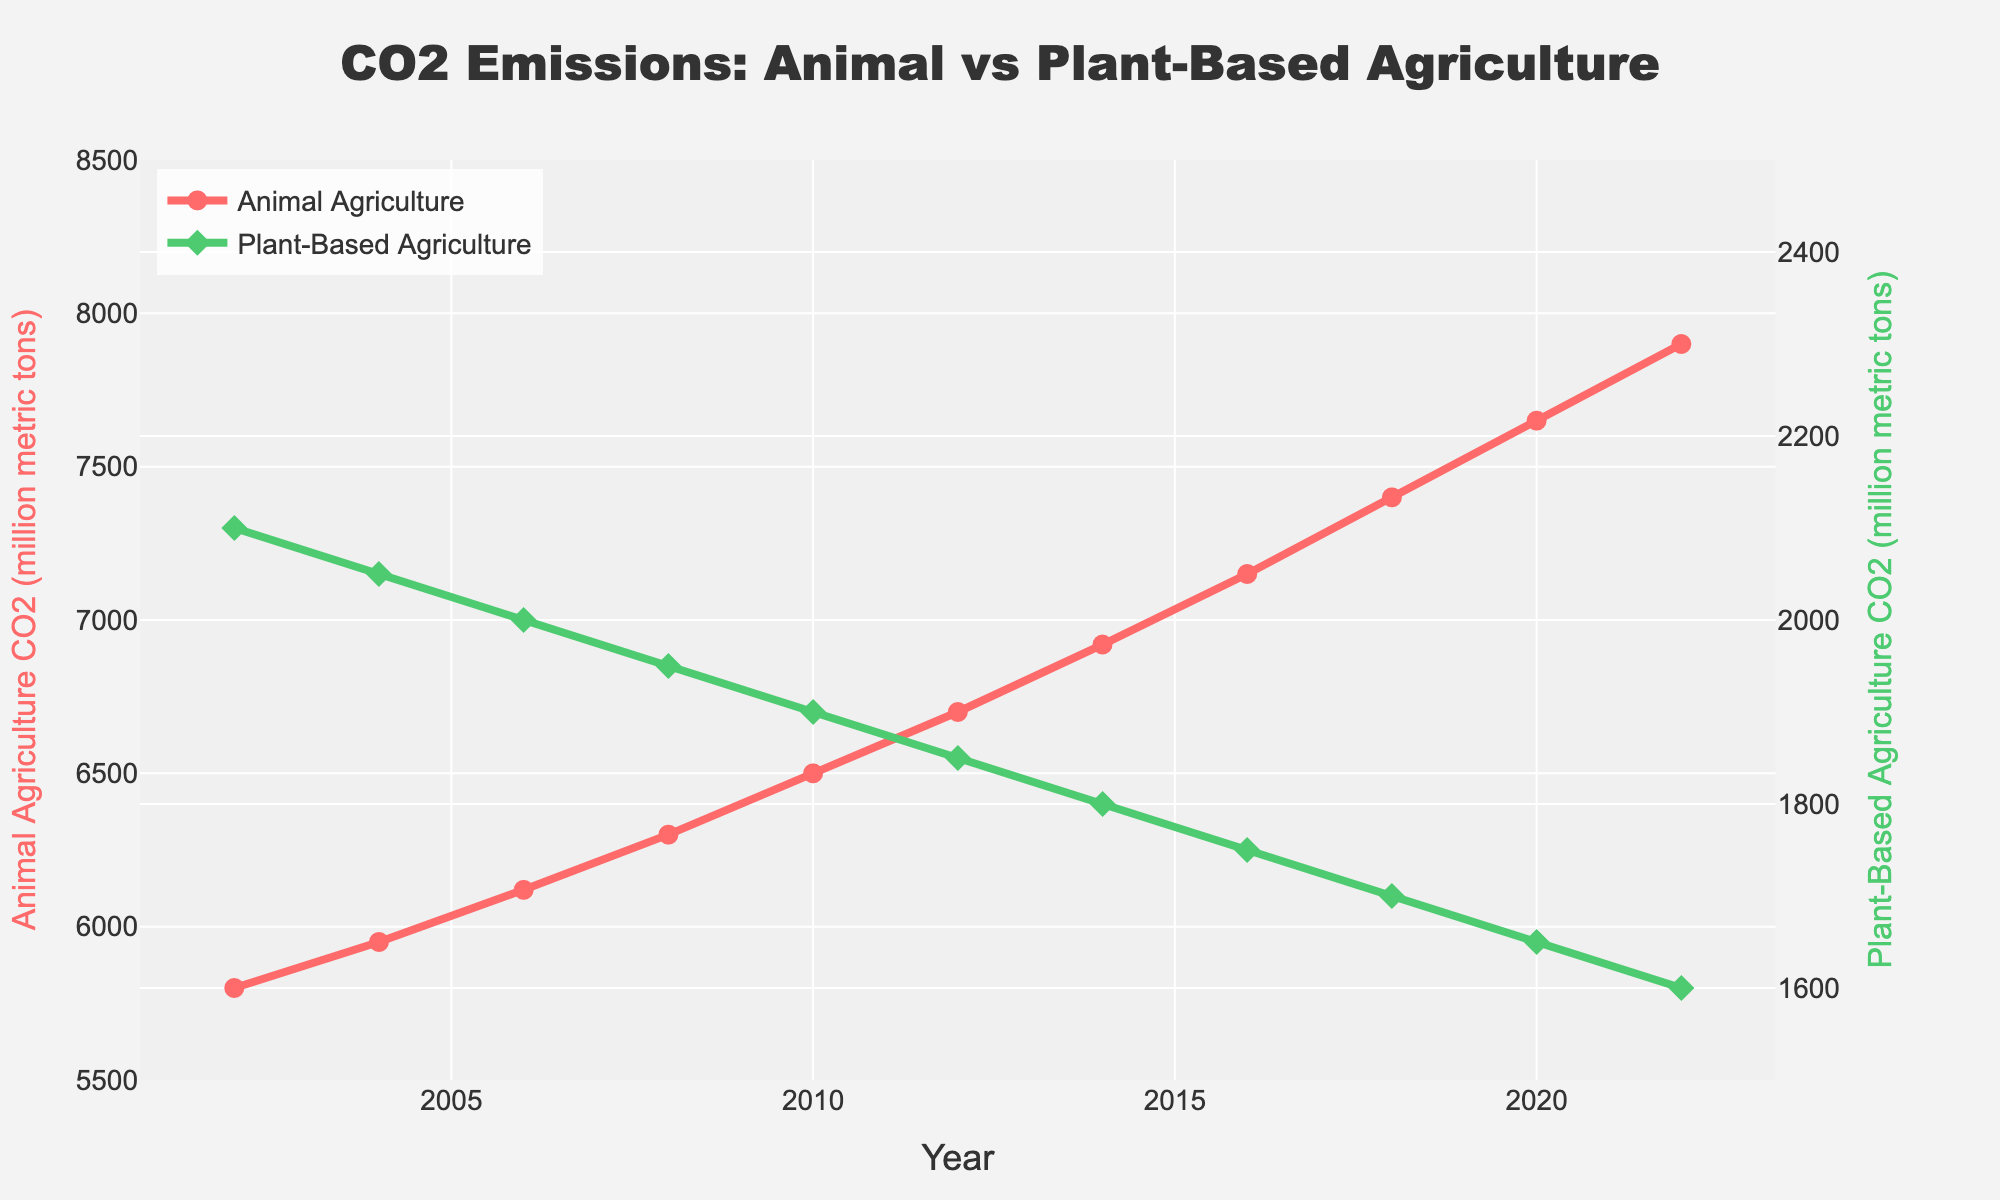What is the general trend in CO2 emissions from animal agriculture over the last 20 years? The line showing animal agriculture CO2 emissions consistently increases from 5800 million metric tons in 2002 to 7900 million metric tons in 2022, indicating a rising trend.
Answer: Increasing How do the CO2 emissions from plant-based agriculture in 2004 compare to those in 2022? In 2004, the CO2 emissions from plant-based agriculture were 2050 million metric tons, while in 2022, they were 1600 million metric tons. This indicates a decrease in emissions over the period.
Answer: Decreased What is the difference in CO2 emissions from animal agriculture between the years 2014 and 2018? In 2014, emissions were 6920 million metric tons, and in 2018 they were 7400 million metric tons. Subtracting 6920 from 7400 gives a difference of 480 million metric tons.
Answer: 480 million metric tons How have the CO2 emissions from plant-based agriculture changed on average each year from 2002 to 2022? In 2002, the emissions were 2100 million metric tons, and in 2022, they were 1600 million metric tons. The total change over 20 years is 2100 - 1600 = 500 million metric tons. Dividing this by 20 years gives an average annual reduction of 25 million metric tons per year.
Answer: 25 million metric tons per year By how much did the CO2 emissions from animal agriculture exceed those from plant-based agriculture in 2020? In 2020, animal agriculture emissions were 7650 million metric tons and plant-based agriculture emissions were 1650 million metric tons. The difference is 7650 - 1650 = 6000 million metric tons.
Answer: 6000 million metric tons At which year did CO2 emissions from animal agriculture reach 6500 million metric tons? The CO2 emissions from animal agriculture reached 6500 million metric tons in the year 2010.
Answer: 2010 What is the percentage decrease in CO2 emissions from plant-based agriculture between 2002 and 2022? In 2002, the emissions were 2100 million metric tons, and in 2022, they were 1600 million metric tons. The decrease is 2100 - 1600 = 500 million metric tons. The percentage decrease is (500 / 2100) * 100 = approximately 23.81%.
Answer: 23.81% In which year did the CO2 emissions from plant-based agriculture fall below 1800 million metric tons? The CO2 emissions from plant-based agriculture fell below 1800 million metric tons in 2014.
Answer: 2014 Between which consecutive years did animal agriculture see the largest increase in CO2 emissions? The largest increase in emissions for animal agriculture occurred between 2008 (6300 million metric tons) and 2010 (6500 million metric tons), resulting in an increase of 200 million metric tons.
Answer: 2008 and 2010 